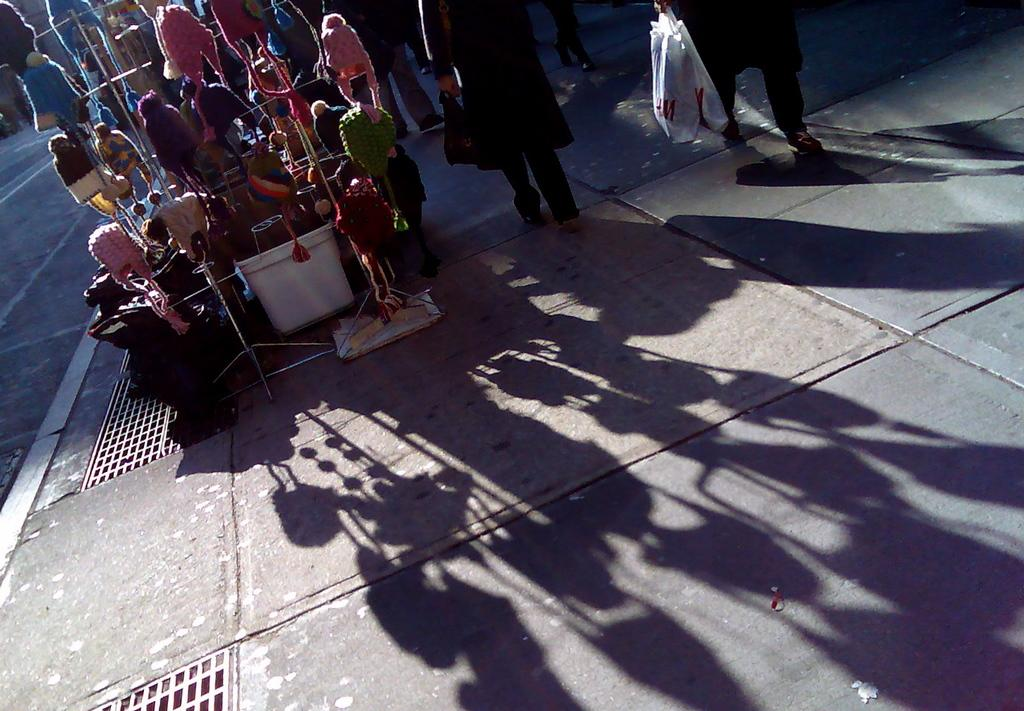What type of stall is in the image? There is a monkey cap stall in the image. What can be seen beside the stall? People are walking on the footpath beside the stall. What is the effect of the sunlight on the stall and people? The shadows of the stall and people are reflected on the ground. What type of stick can be seen in the image? There is no stick present in the image. Is there a church visible in the image? No, there is no church visible in the image; it only features a monkey cap stall and people walking on a footpath. 